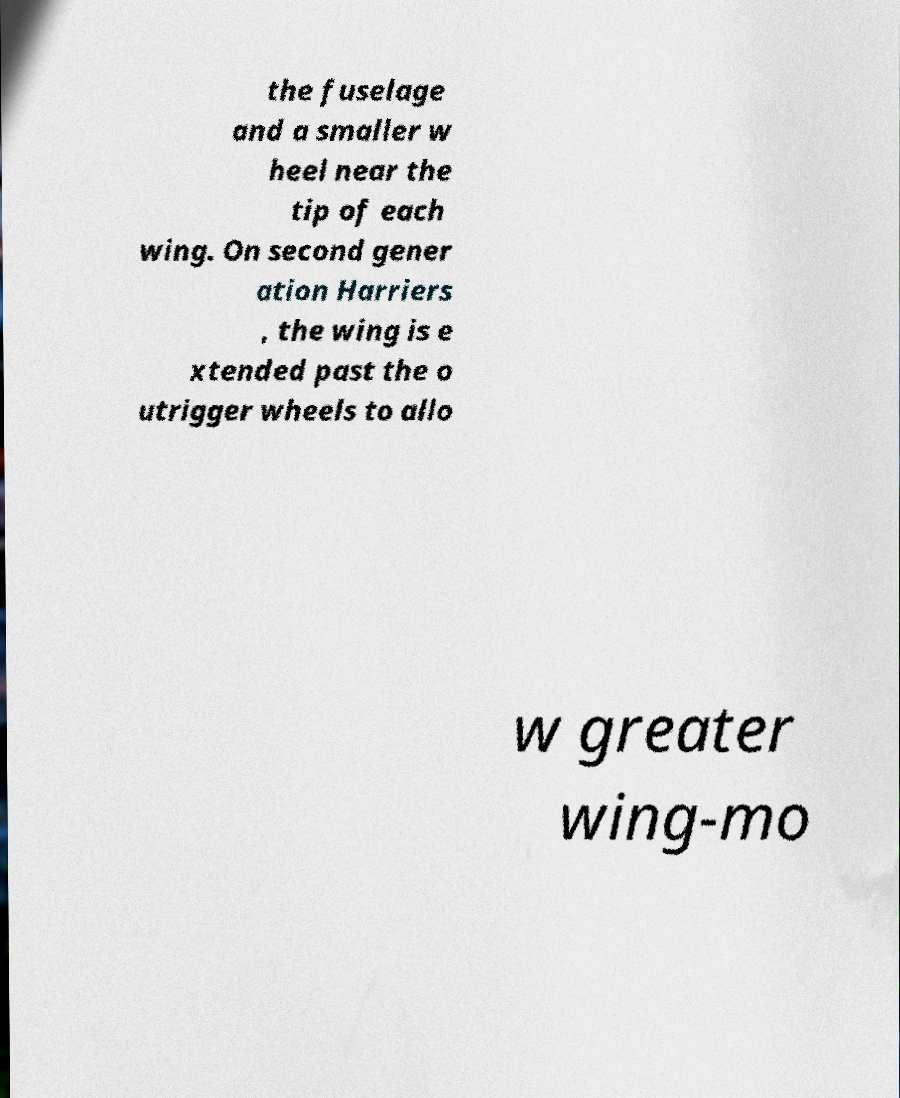Can you accurately transcribe the text from the provided image for me? the fuselage and a smaller w heel near the tip of each wing. On second gener ation Harriers , the wing is e xtended past the o utrigger wheels to allo w greater wing-mo 